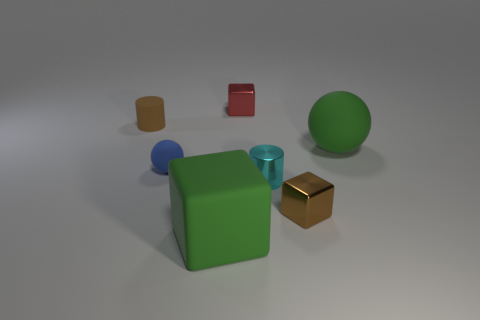Add 3 big green cubes. How many objects exist? 10 Subtract all balls. How many objects are left? 5 Add 5 metallic things. How many metallic things exist? 8 Subtract 0 cyan balls. How many objects are left? 7 Subtract all small blue shiny blocks. Subtract all big green matte cubes. How many objects are left? 6 Add 4 tiny cubes. How many tiny cubes are left? 6 